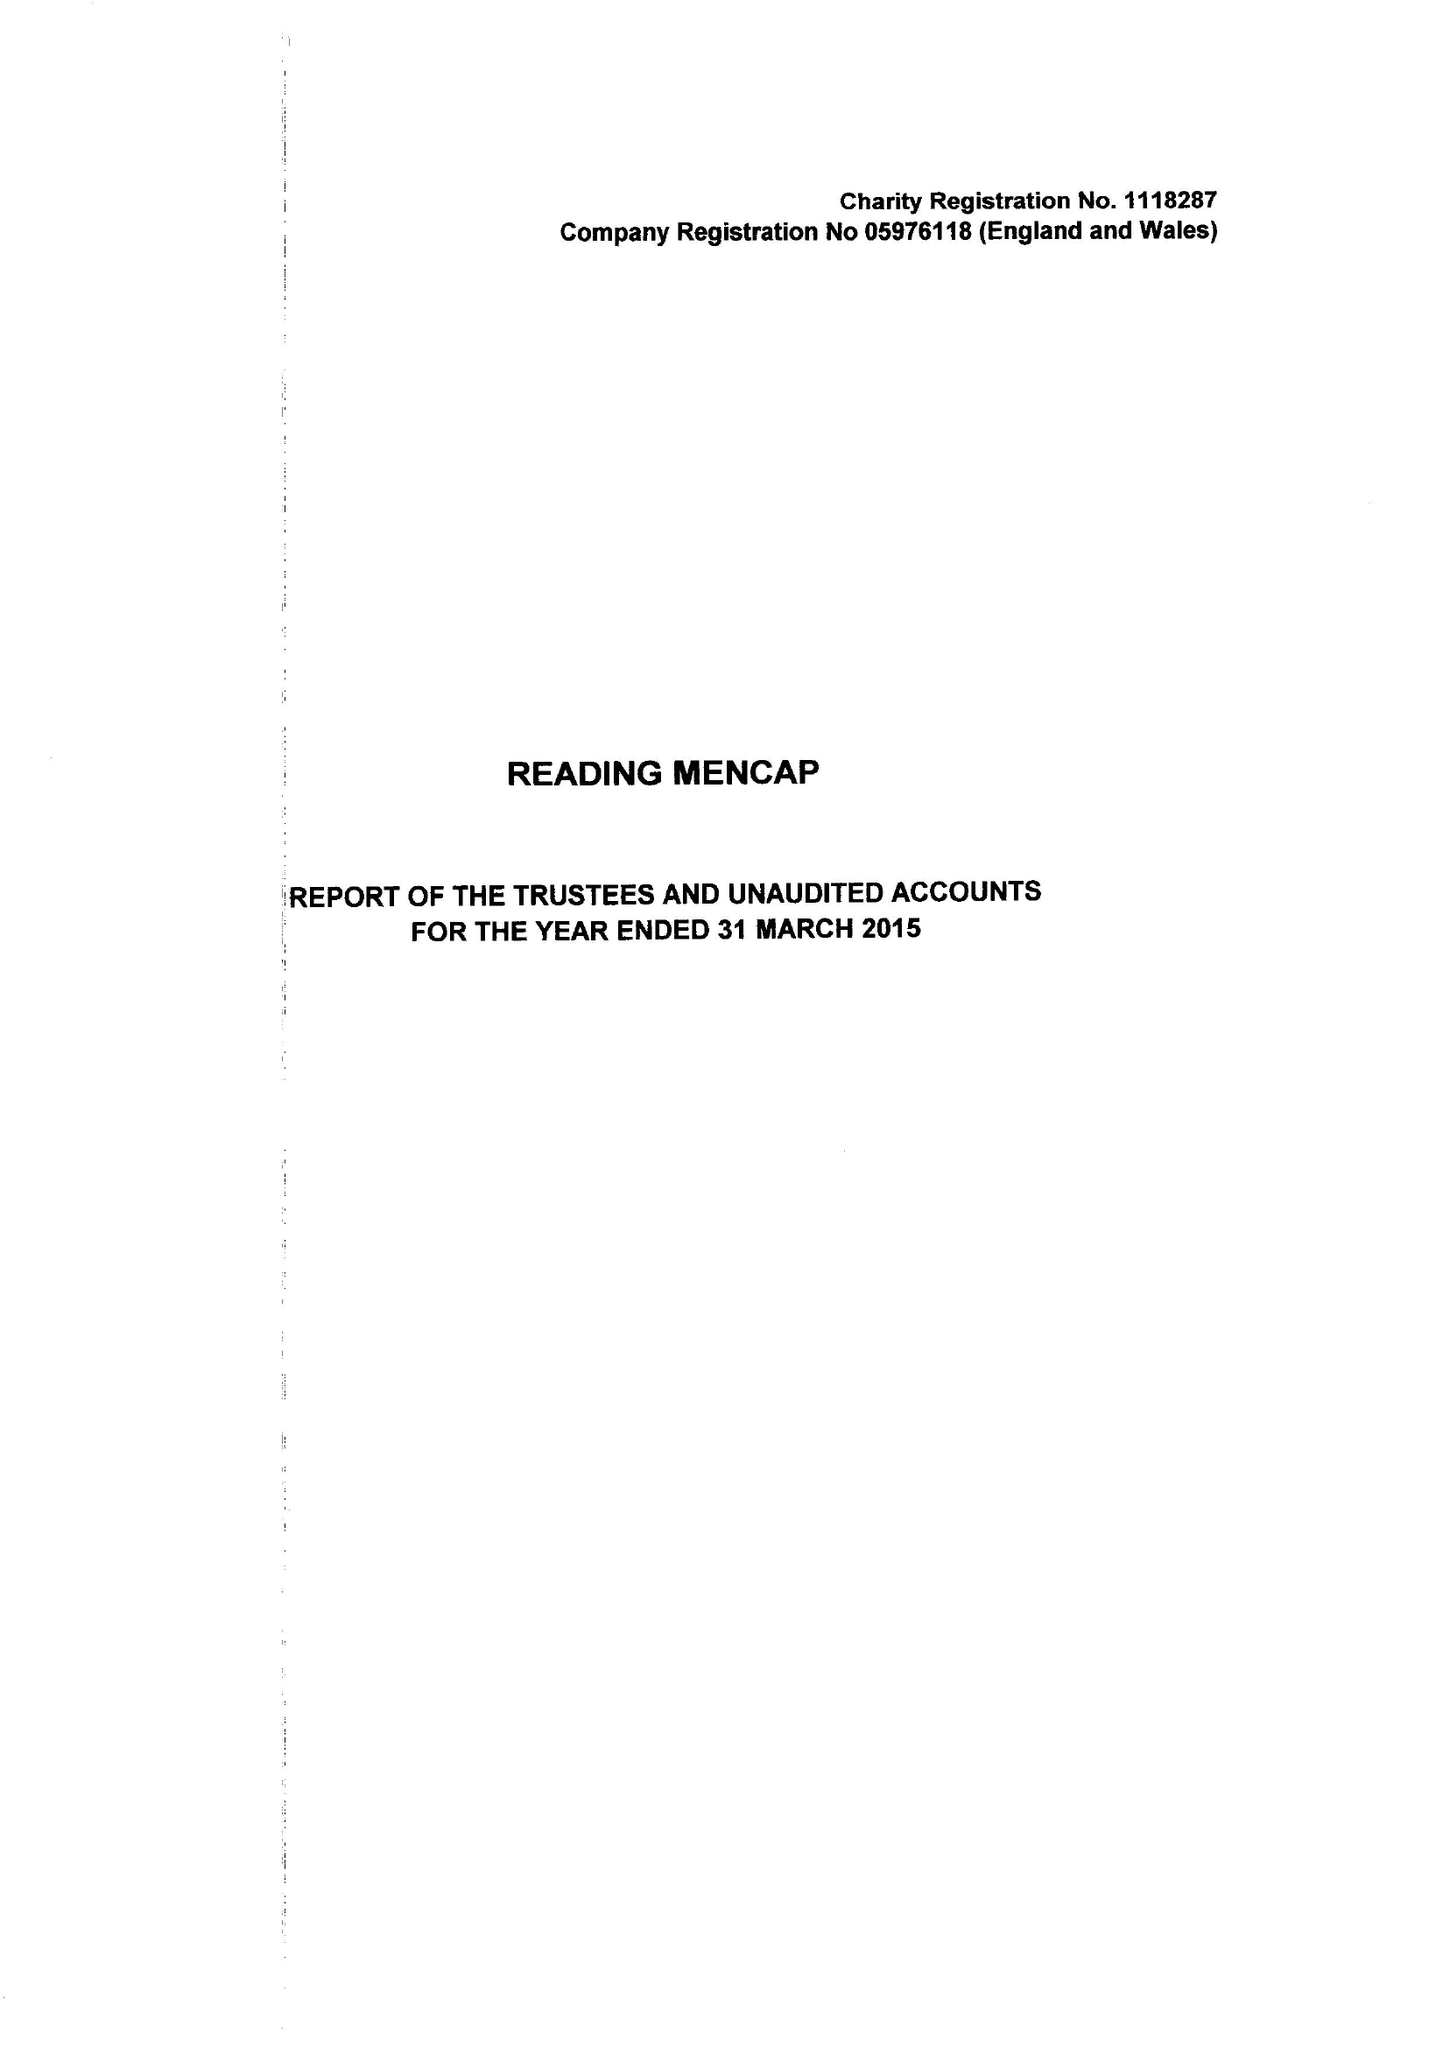What is the value for the report_date?
Answer the question using a single word or phrase. 2015-03-31 